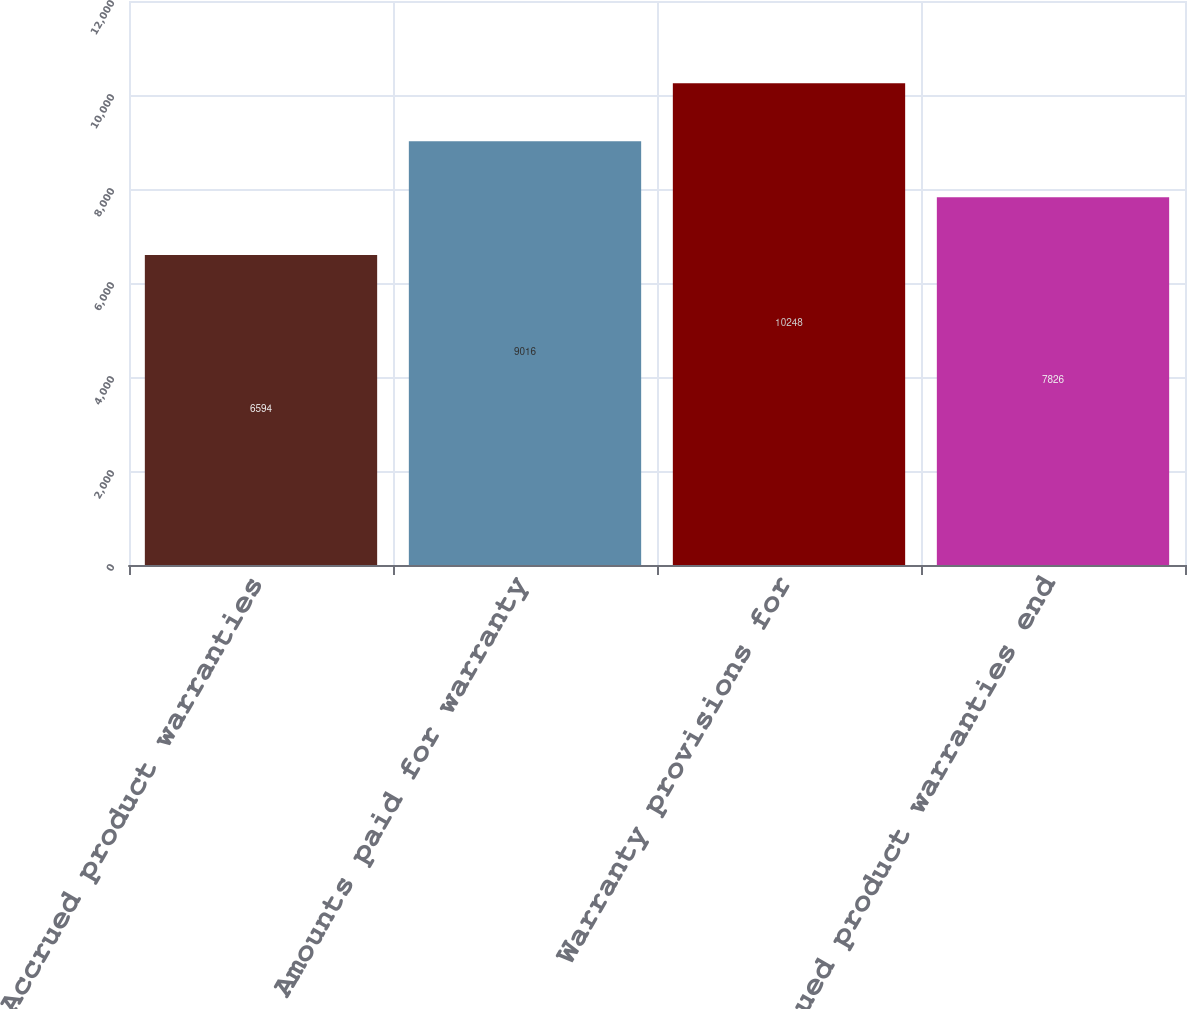Convert chart to OTSL. <chart><loc_0><loc_0><loc_500><loc_500><bar_chart><fcel>Accrued product warranties<fcel>Amounts paid for warranty<fcel>Warranty provisions for<fcel>Accrued product warranties end<nl><fcel>6594<fcel>9016<fcel>10248<fcel>7826<nl></chart> 